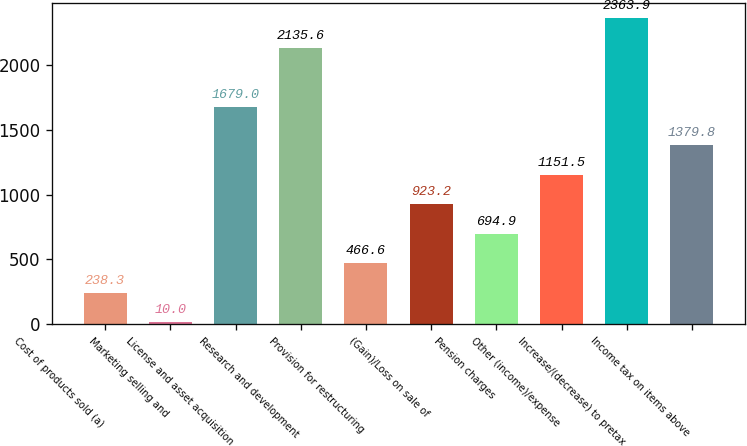Convert chart to OTSL. <chart><loc_0><loc_0><loc_500><loc_500><bar_chart><fcel>Cost of products sold (a)<fcel>Marketing selling and<fcel>License and asset acquisition<fcel>Research and development<fcel>Provision for restructuring<fcel>(Gain)/Loss on sale of<fcel>Pension charges<fcel>Other (income)/expense<fcel>Increase/(decrease) to pretax<fcel>Income tax on items above<nl><fcel>238.3<fcel>10<fcel>1679<fcel>2135.6<fcel>466.6<fcel>923.2<fcel>694.9<fcel>1151.5<fcel>2363.9<fcel>1379.8<nl></chart> 